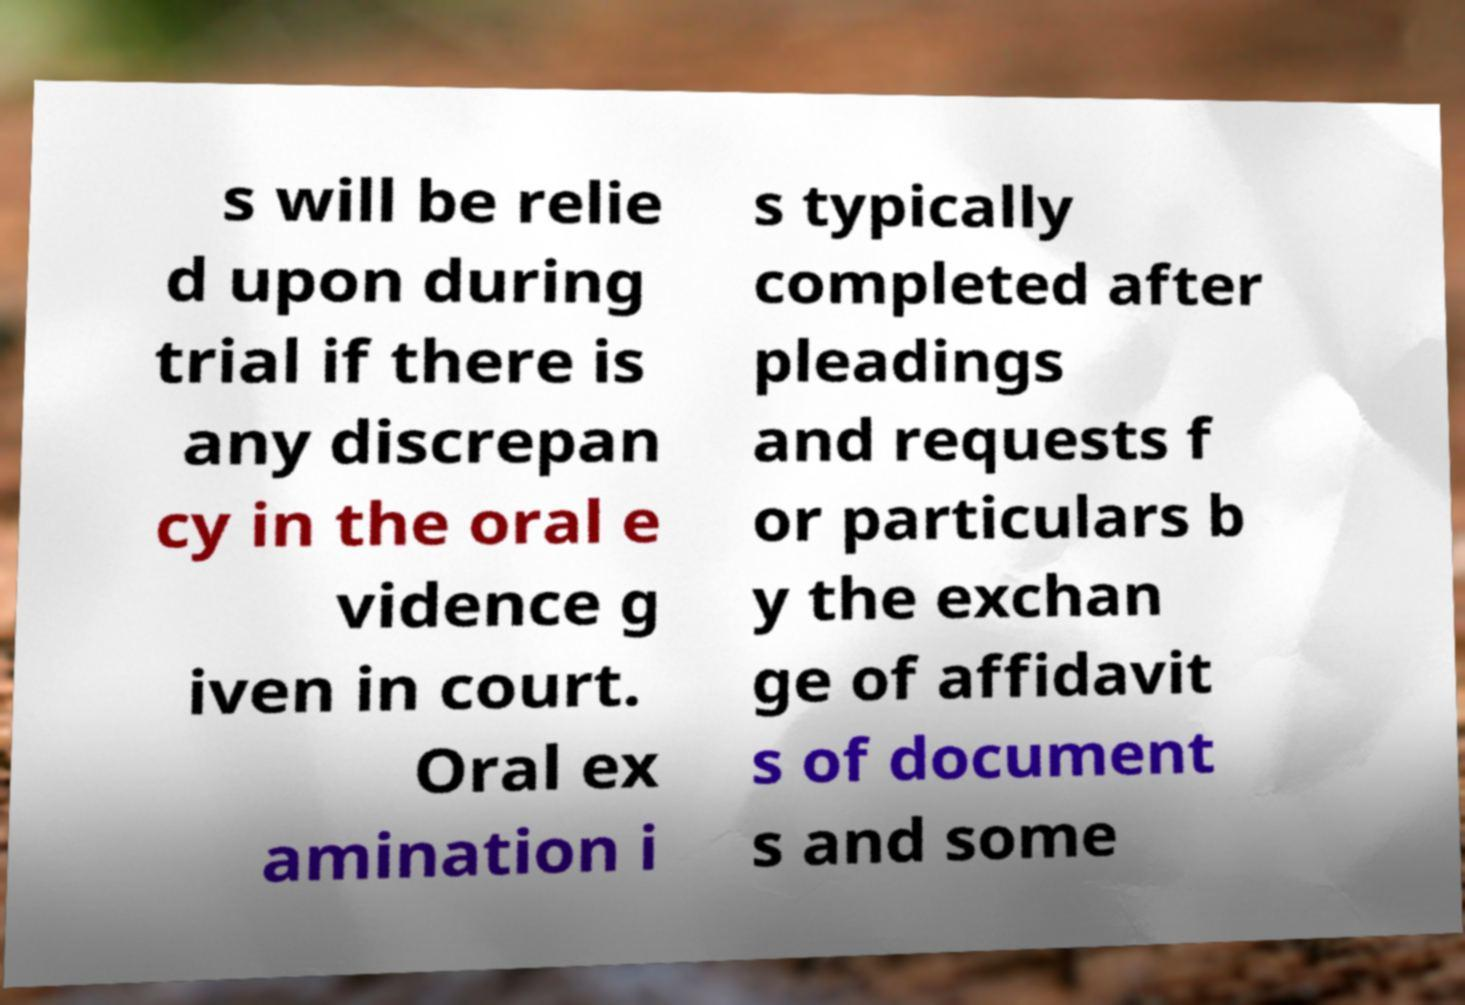Can you read and provide the text displayed in the image?This photo seems to have some interesting text. Can you extract and type it out for me? s will be relie d upon during trial if there is any discrepan cy in the oral e vidence g iven in court. Oral ex amination i s typically completed after pleadings and requests f or particulars b y the exchan ge of affidavit s of document s and some 